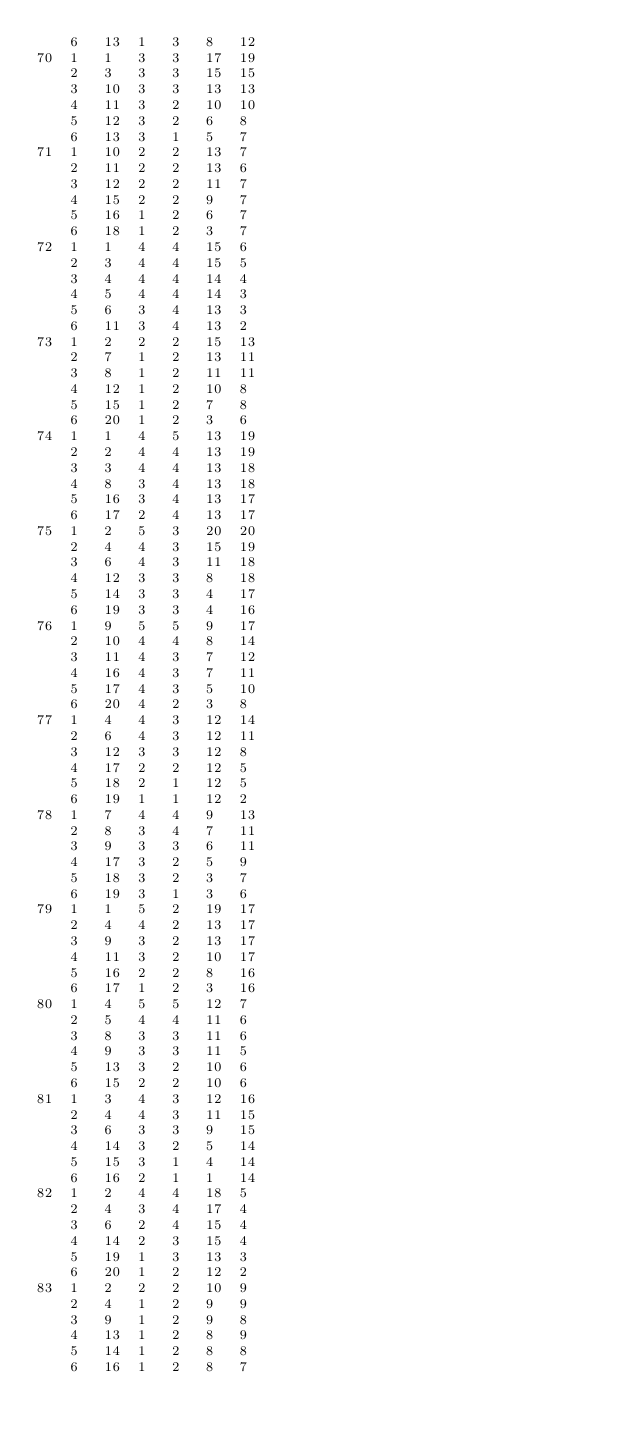Convert code to text. <code><loc_0><loc_0><loc_500><loc_500><_ObjectiveC_>	6	13	1	3	8	12	
70	1	1	3	3	17	19	
	2	3	3	3	15	15	
	3	10	3	3	13	13	
	4	11	3	2	10	10	
	5	12	3	2	6	8	
	6	13	3	1	5	7	
71	1	10	2	2	13	7	
	2	11	2	2	13	6	
	3	12	2	2	11	7	
	4	15	2	2	9	7	
	5	16	1	2	6	7	
	6	18	1	2	3	7	
72	1	1	4	4	15	6	
	2	3	4	4	15	5	
	3	4	4	4	14	4	
	4	5	4	4	14	3	
	5	6	3	4	13	3	
	6	11	3	4	13	2	
73	1	2	2	2	15	13	
	2	7	1	2	13	11	
	3	8	1	2	11	11	
	4	12	1	2	10	8	
	5	15	1	2	7	8	
	6	20	1	2	3	6	
74	1	1	4	5	13	19	
	2	2	4	4	13	19	
	3	3	4	4	13	18	
	4	8	3	4	13	18	
	5	16	3	4	13	17	
	6	17	2	4	13	17	
75	1	2	5	3	20	20	
	2	4	4	3	15	19	
	3	6	4	3	11	18	
	4	12	3	3	8	18	
	5	14	3	3	4	17	
	6	19	3	3	4	16	
76	1	9	5	5	9	17	
	2	10	4	4	8	14	
	3	11	4	3	7	12	
	4	16	4	3	7	11	
	5	17	4	3	5	10	
	6	20	4	2	3	8	
77	1	4	4	3	12	14	
	2	6	4	3	12	11	
	3	12	3	3	12	8	
	4	17	2	2	12	5	
	5	18	2	1	12	5	
	6	19	1	1	12	2	
78	1	7	4	4	9	13	
	2	8	3	4	7	11	
	3	9	3	3	6	11	
	4	17	3	2	5	9	
	5	18	3	2	3	7	
	6	19	3	1	3	6	
79	1	1	5	2	19	17	
	2	4	4	2	13	17	
	3	9	3	2	13	17	
	4	11	3	2	10	17	
	5	16	2	2	8	16	
	6	17	1	2	3	16	
80	1	4	5	5	12	7	
	2	5	4	4	11	6	
	3	8	3	3	11	6	
	4	9	3	3	11	5	
	5	13	3	2	10	6	
	6	15	2	2	10	6	
81	1	3	4	3	12	16	
	2	4	4	3	11	15	
	3	6	3	3	9	15	
	4	14	3	2	5	14	
	5	15	3	1	4	14	
	6	16	2	1	1	14	
82	1	2	4	4	18	5	
	2	4	3	4	17	4	
	3	6	2	4	15	4	
	4	14	2	3	15	4	
	5	19	1	3	13	3	
	6	20	1	2	12	2	
83	1	2	2	2	10	9	
	2	4	1	2	9	9	
	3	9	1	2	9	8	
	4	13	1	2	8	9	
	5	14	1	2	8	8	
	6	16	1	2	8	7	</code> 